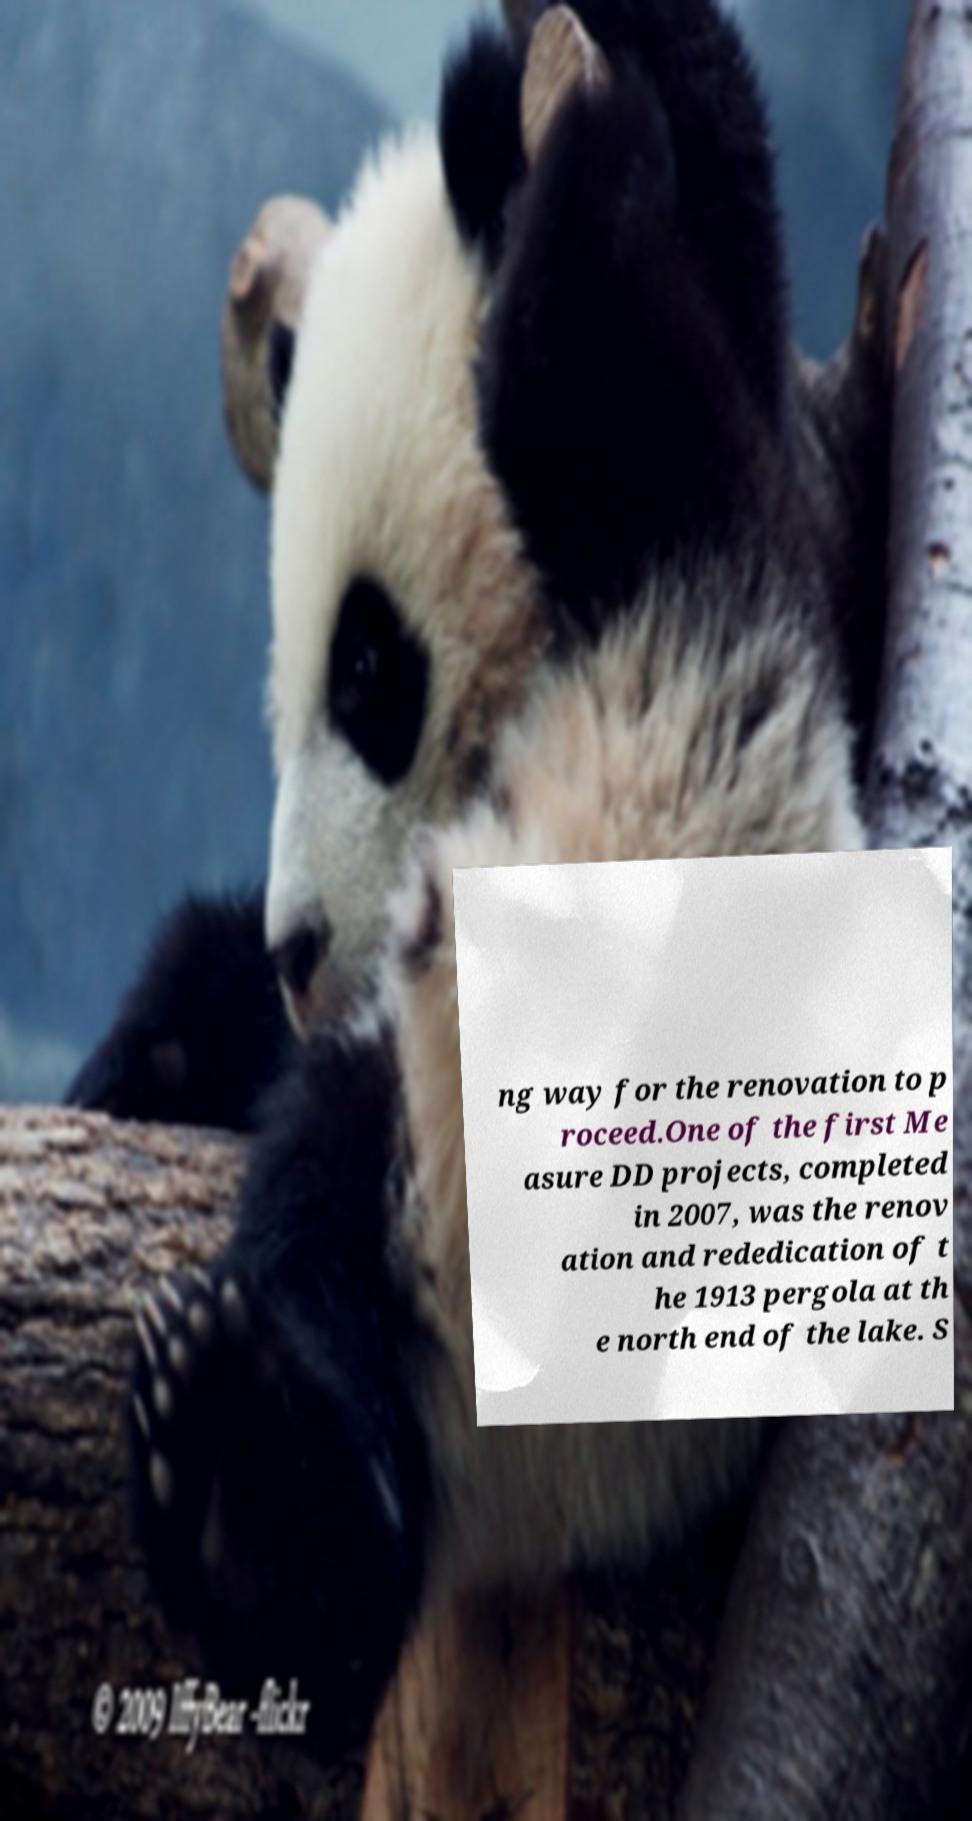For documentation purposes, I need the text within this image transcribed. Could you provide that? ng way for the renovation to p roceed.One of the first Me asure DD projects, completed in 2007, was the renov ation and rededication of t he 1913 pergola at th e north end of the lake. S 